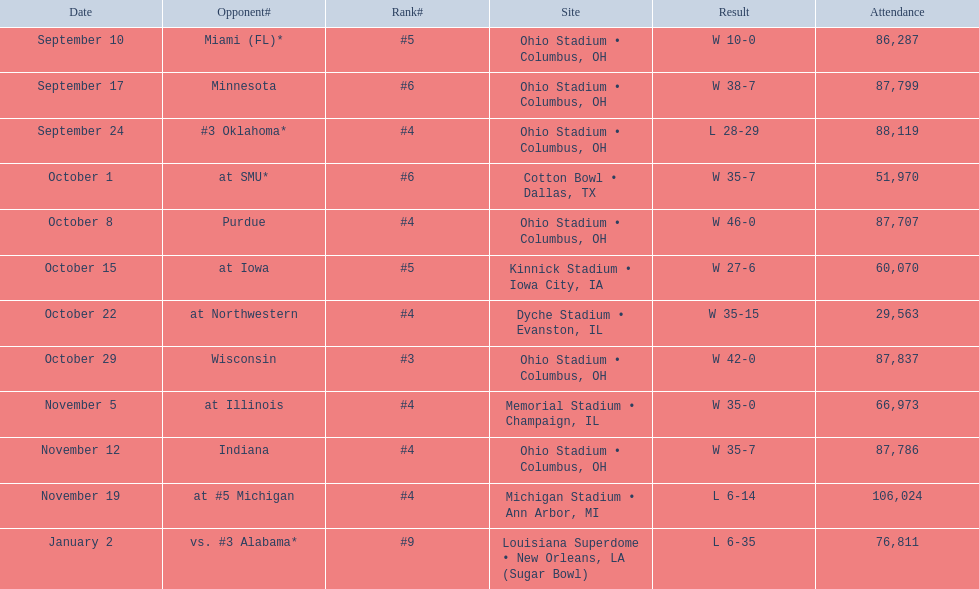What is the disparity between the total victories and total defeats? 6. 